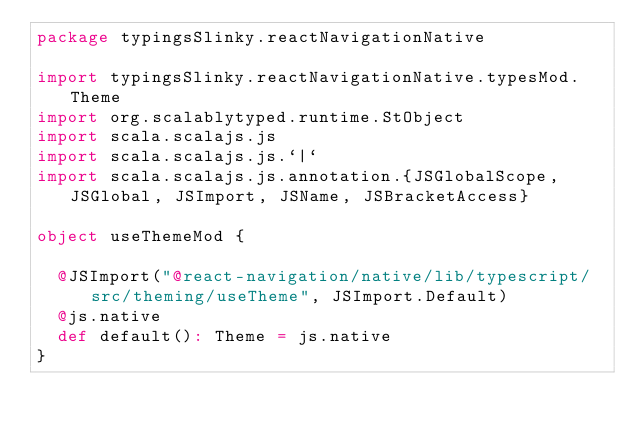Convert code to text. <code><loc_0><loc_0><loc_500><loc_500><_Scala_>package typingsSlinky.reactNavigationNative

import typingsSlinky.reactNavigationNative.typesMod.Theme
import org.scalablytyped.runtime.StObject
import scala.scalajs.js
import scala.scalajs.js.`|`
import scala.scalajs.js.annotation.{JSGlobalScope, JSGlobal, JSImport, JSName, JSBracketAccess}

object useThemeMod {
  
  @JSImport("@react-navigation/native/lib/typescript/src/theming/useTheme", JSImport.Default)
  @js.native
  def default(): Theme = js.native
}
</code> 